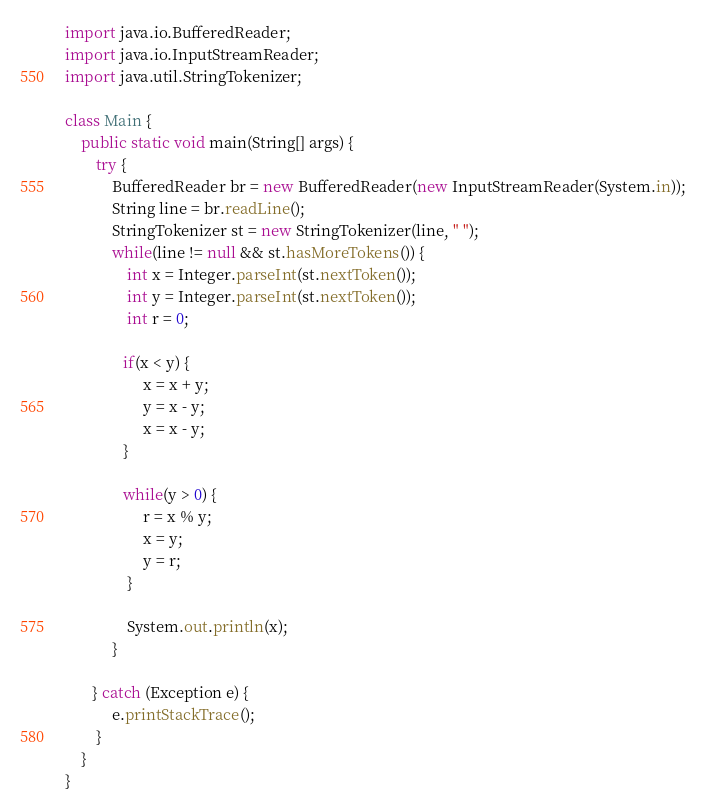<code> <loc_0><loc_0><loc_500><loc_500><_Java_>import java.io.BufferedReader;
import java.io.InputStreamReader;
import java.util.StringTokenizer;

class Main {
    public static void main(String[] args) {
        try {
            BufferedReader br = new BufferedReader(new InputStreamReader(System.in));
            String line = br.readLine();
            StringTokenizer st = new StringTokenizer(line, " ");
            while(line != null && st.hasMoreTokens()) {
                int x = Integer.parseInt(st.nextToken());
                int y = Integer.parseInt(st.nextToken());
                int r = 0;

               if(x < y) {
                    x = x + y;
                    y = x - y;
                    x = x - y;
               }

               while(y > 0) {
                    r = x % y;
                    x = y;
                    y = r;
                }

                System.out.println(x);
            }

       } catch (Exception e) {
            e.printStackTrace();
        }
    }
}</code> 